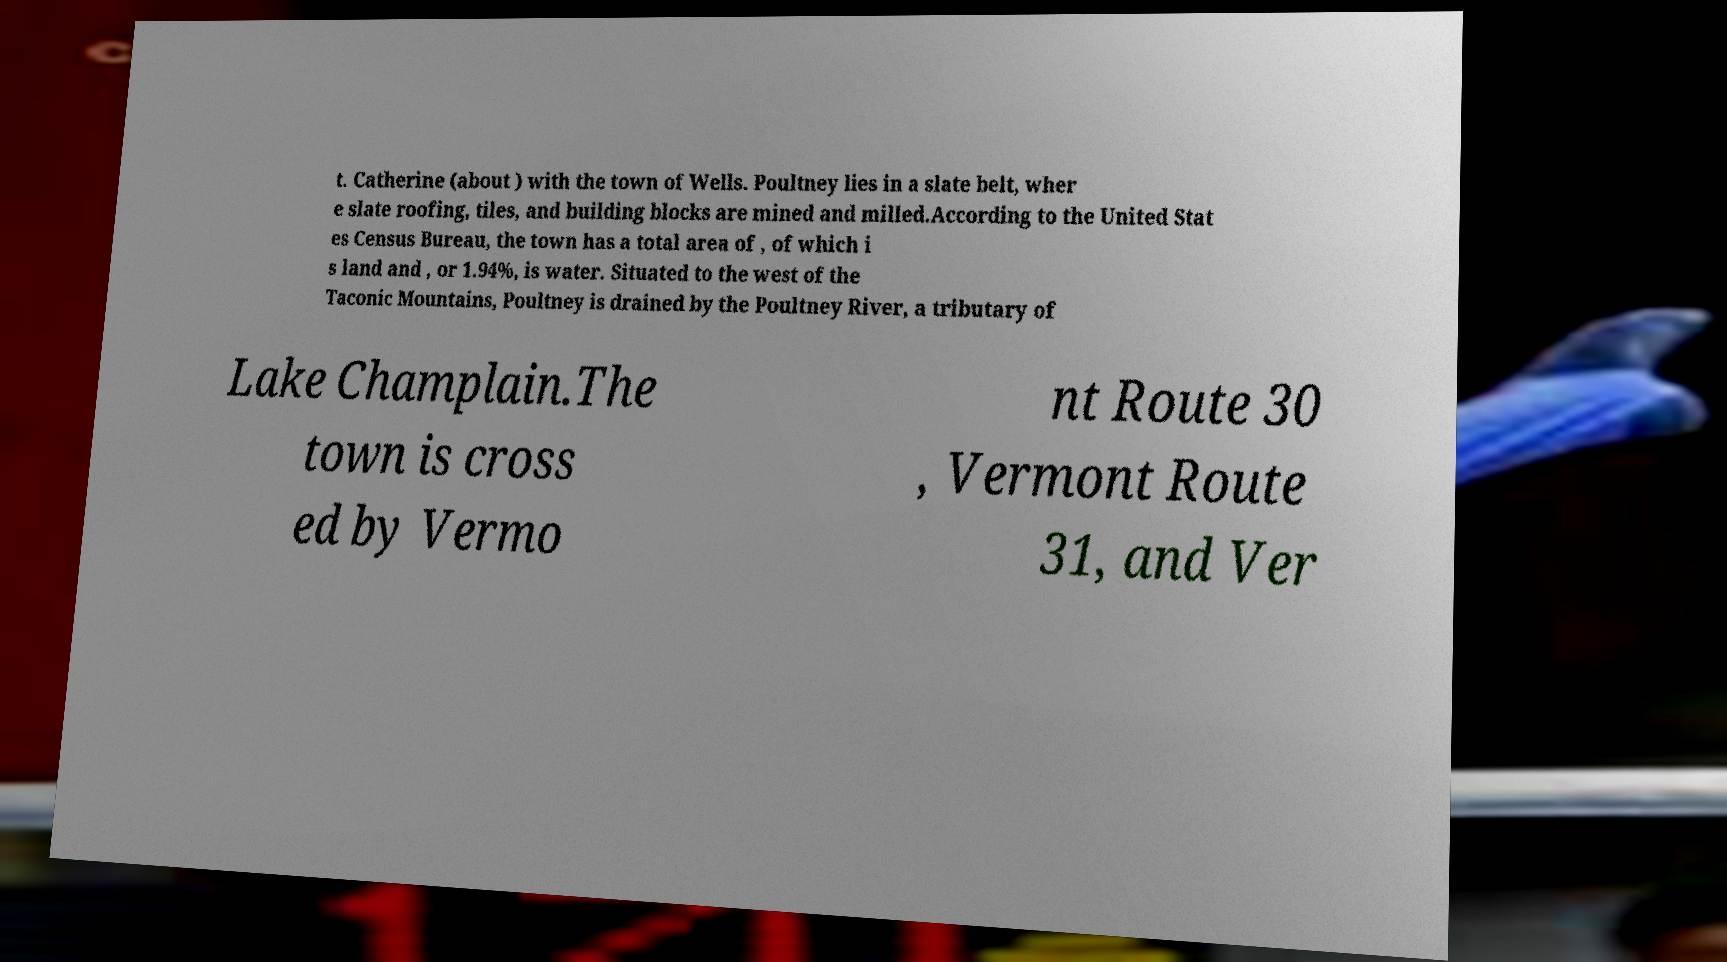Can you read and provide the text displayed in the image?This photo seems to have some interesting text. Can you extract and type it out for me? t. Catherine (about ) with the town of Wells. Poultney lies in a slate belt, wher e slate roofing, tiles, and building blocks are mined and milled.According to the United Stat es Census Bureau, the town has a total area of , of which i s land and , or 1.94%, is water. Situated to the west of the Taconic Mountains, Poultney is drained by the Poultney River, a tributary of Lake Champlain.The town is cross ed by Vermo nt Route 30 , Vermont Route 31, and Ver 